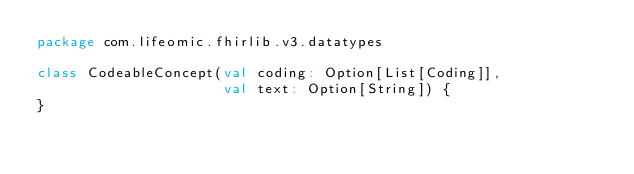Convert code to text. <code><loc_0><loc_0><loc_500><loc_500><_Scala_>package com.lifeomic.fhirlib.v3.datatypes

class CodeableConcept(val coding: Option[List[Coding]],
                      val text: Option[String]) {
}
</code> 